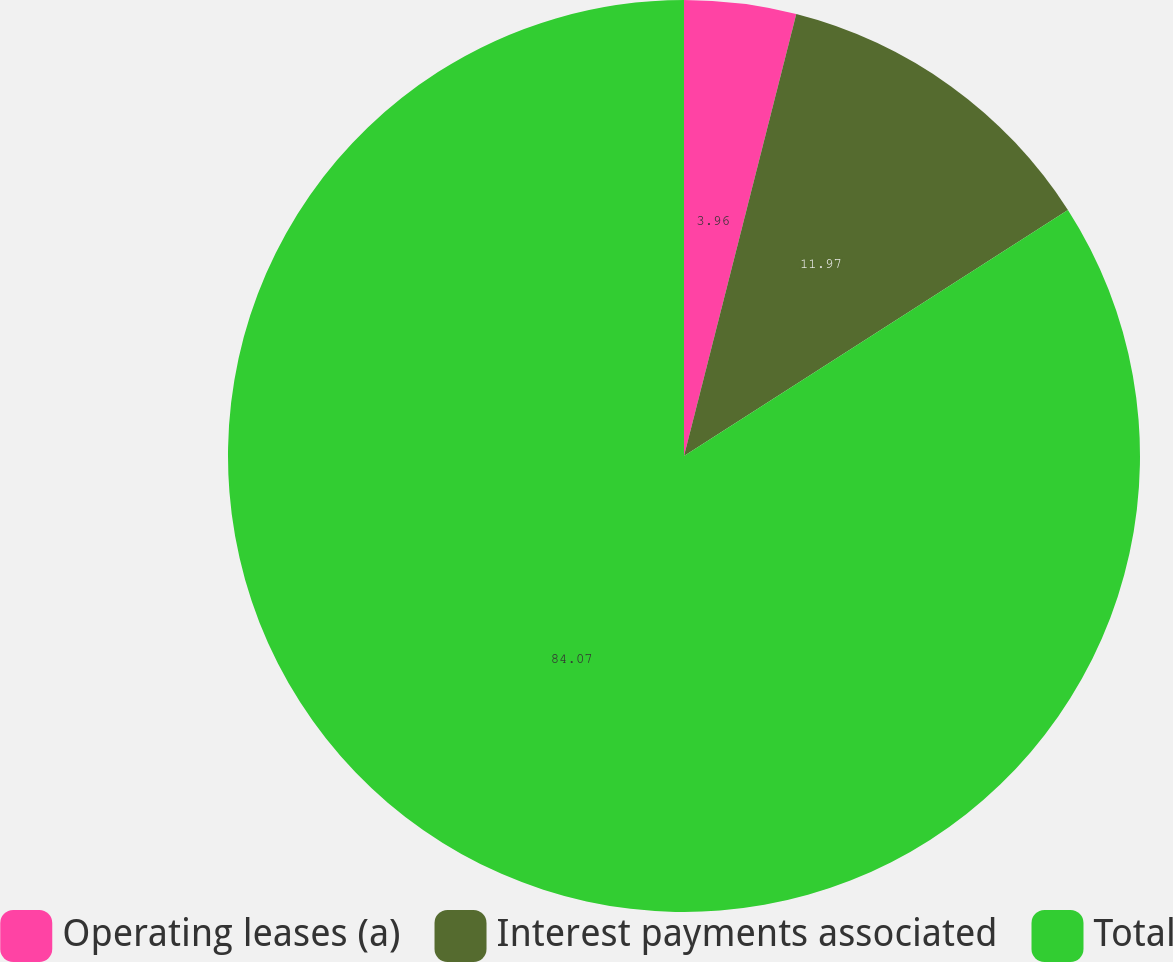Convert chart to OTSL. <chart><loc_0><loc_0><loc_500><loc_500><pie_chart><fcel>Operating leases (a)<fcel>Interest payments associated<fcel>Total<nl><fcel>3.96%<fcel>11.97%<fcel>84.07%<nl></chart> 